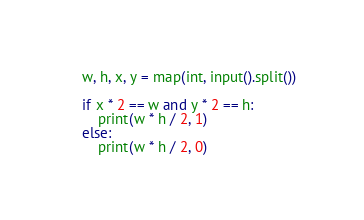<code> <loc_0><loc_0><loc_500><loc_500><_Python_>w, h, x, y = map(int, input().split())

if x * 2 == w and y * 2 == h:
    print(w * h / 2, 1)
else:
    print(w * h / 2, 0)</code> 